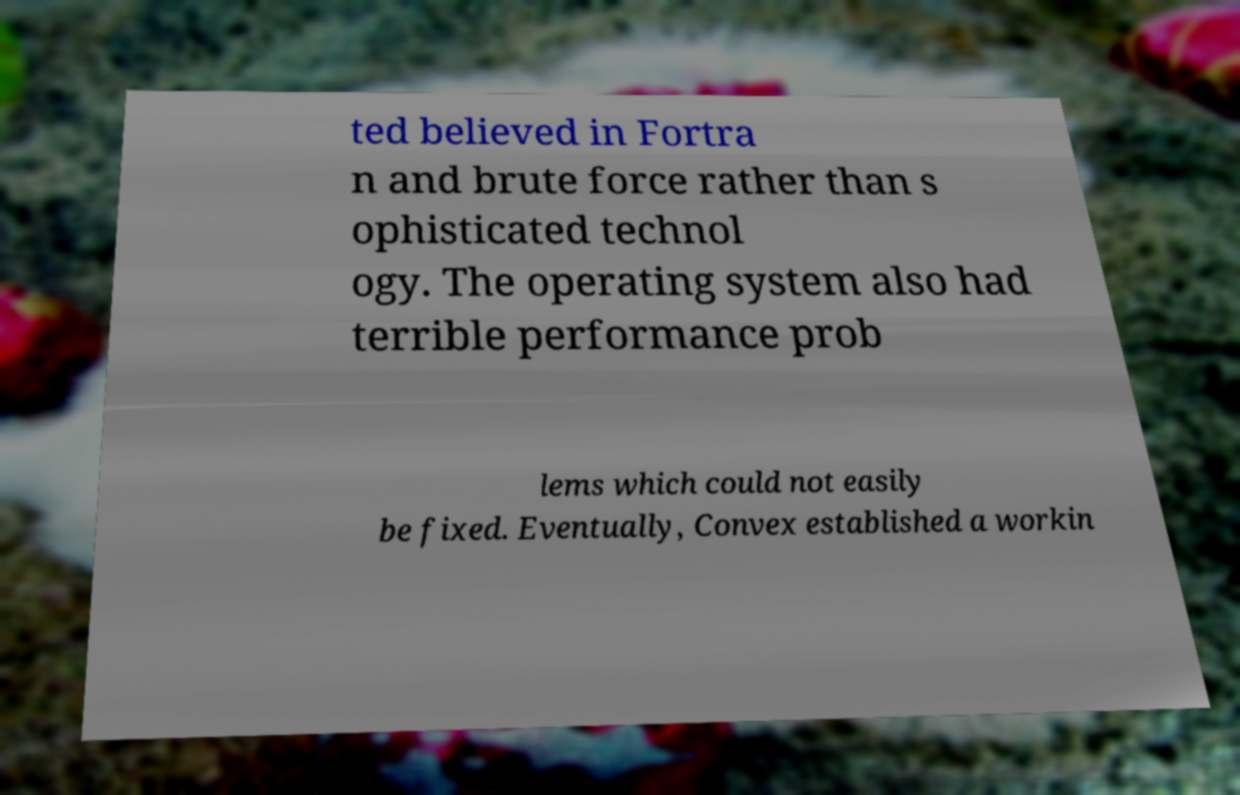Can you read and provide the text displayed in the image?This photo seems to have some interesting text. Can you extract and type it out for me? ted believed in Fortra n and brute force rather than s ophisticated technol ogy. The operating system also had terrible performance prob lems which could not easily be fixed. Eventually, Convex established a workin 